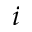<formula> <loc_0><loc_0><loc_500><loc_500>i</formula> 